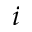<formula> <loc_0><loc_0><loc_500><loc_500>i</formula> 